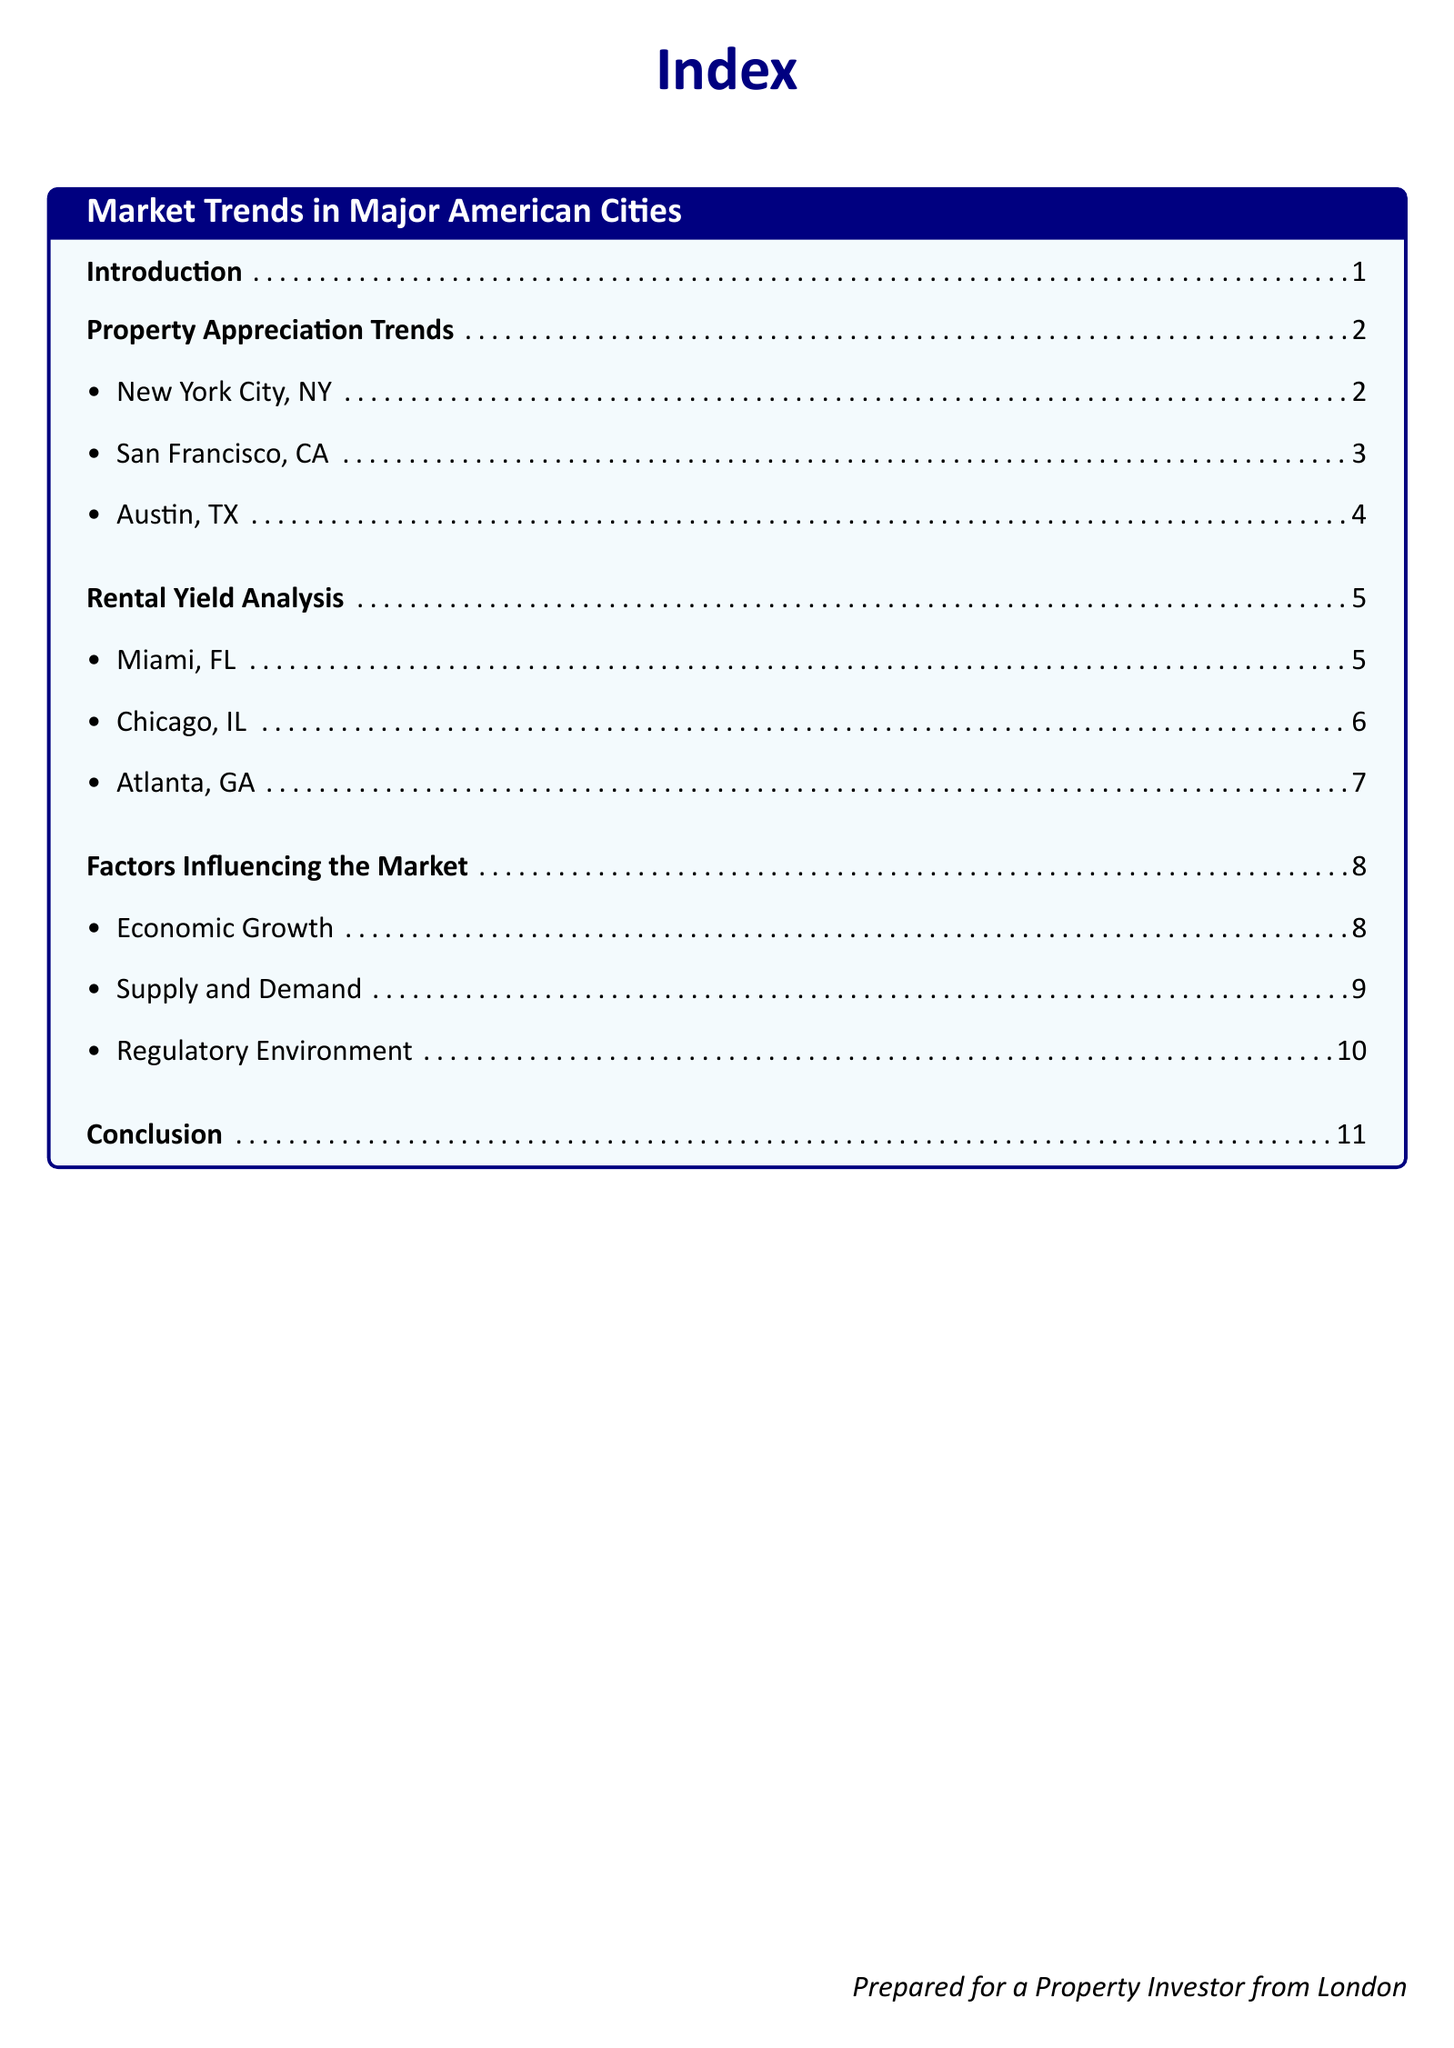What is the title of the document? The title is indicated at the beginning of the document as a central text.
Answer: Index How many major cities are analyzed for property appreciation trends? The document lists three cities under property appreciation trends.
Answer: 3 Which city is analyzed for rental yield analysis first? The order of cities is mentioned in a list format, with Miami listed first.
Answer: Miami, FL What is the first factor influencing the market mentioned? The document provides a list of factors influencing the market, starting with economic growth.
Answer: Economic Growth What section does the conclusion appear in? The conclusion section title is provided in the index along with its position.
Answer: Conclusion Which city is mentioned under property appreciation trends for Texas? The document specifies Austin, TX in the property appreciation trends section.
Answer: Austin, TX How many rental yield cities are listed in total? The index shows a complete list of three cities under rental yield analysis.
Answer: 3 What color is used for the title of the document? The title uses a specific color mentioned in the document's stylization.
Answer: Navy blue What is the page number for economic growth? The document provides a specific page number for this section in the index.
Answer: 8 